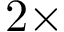Convert formula to latex. <formula><loc_0><loc_0><loc_500><loc_500>2 \times</formula> 